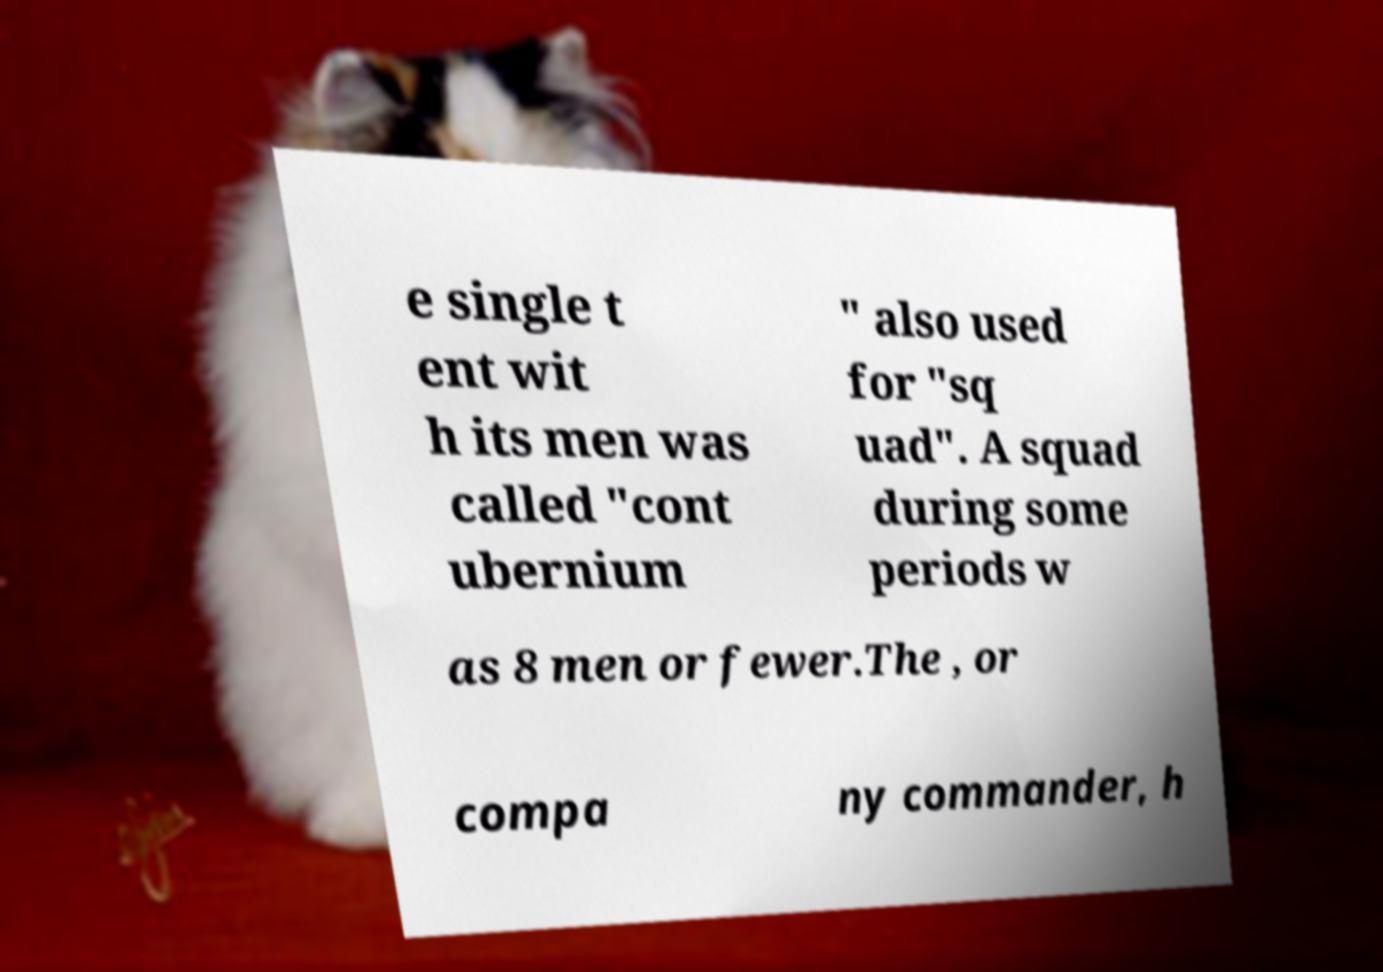There's text embedded in this image that I need extracted. Can you transcribe it verbatim? e single t ent wit h its men was called "cont ubernium " also used for "sq uad". A squad during some periods w as 8 men or fewer.The , or compa ny commander, h 